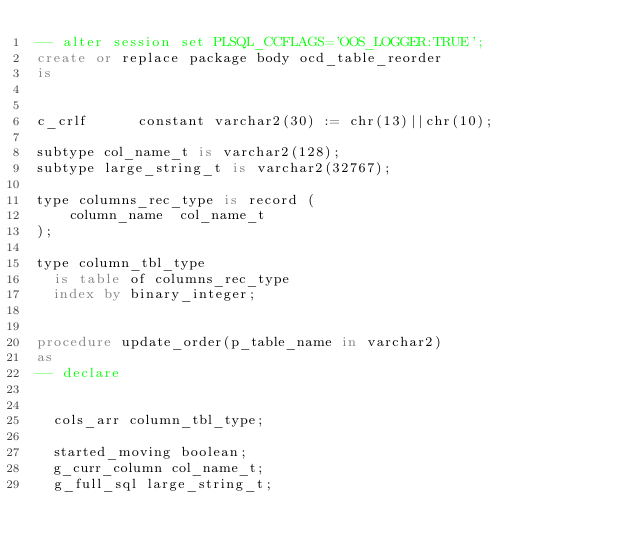<code> <loc_0><loc_0><loc_500><loc_500><_SQL_>-- alter session set PLSQL_CCFLAGS='OOS_LOGGER:TRUE';
create or replace package body ocd_table_reorder
is


c_crlf      constant varchar2(30) := chr(13)||chr(10);

subtype col_name_t is varchar2(128);
subtype large_string_t is varchar2(32767);

type columns_rec_type is record (
    column_name  col_name_t
);

type column_tbl_type
  is table of columns_rec_type
  index by binary_integer;


procedure update_order(p_table_name in varchar2)
as
-- declare


  cols_arr column_tbl_type;

  started_moving boolean;
  g_curr_column col_name_t;
  g_full_sql large_string_t;
  </code> 